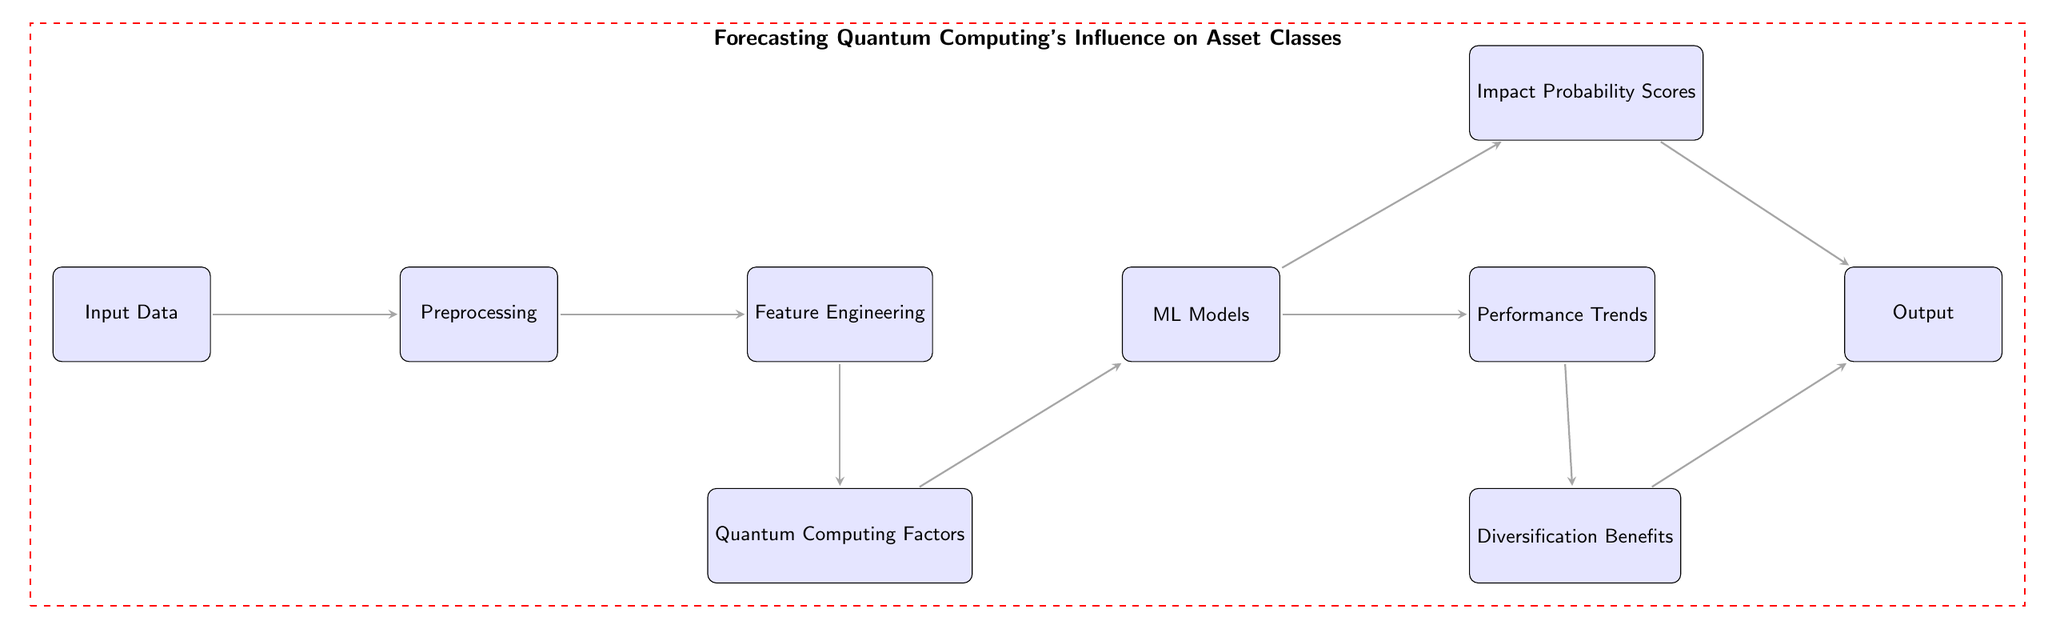What is the first node of the diagram? The first node in the diagram is labeled "Input Data," which indicates it is the initial stage of the process.
Answer: Input Data How many main nodes are involved in the processing flow? The diagram has a total of nine main nodes, each representing a step in the process of forecasting quantum computing's influence.
Answer: Nine What type of model is utilized in the diagram? The diagram specifies the use of "ML Models," indicating that machine learning methodologies are being applied in the forecasting process.
Answer: ML Models Which node corresponds to diversification benefits? The node that represents diversification benefits is labeled "Diversification Benefits," showing it is an output derived from the model's results.
Answer: Diversification Benefits How does the "Quantum Computing Factors" influence the "ML Models"? The "Quantum Computing Factors" node contributes data and considerations to the "ML Models," implying that factors related to quantum computing are essential inputs for the modeling process.
Answer: Through input What are the two outputs generated from "ML Models"? The two outputs from the "ML Models" are "Impact Probability Scores" and "Performance Trends," indicating different aspects of the forecasting results.
Answer: Impact Probability Scores and Performance Trends Which nodes feed directly into the final output node? The final output node receives inputs from "Impact Probability Scores" and "Diversification Benefits," which together inform the overall result provided by the model.
Answer: Impact Probability Scores and Diversification Benefits Identify the relationship between "Performance Trends" and "Diversification Benefits." The relationship is that both "Performance Trends" and "Diversification Benefits" inform the final output, showing that they represent different computations contributing to the overall forecasting results.
Answer: Both contribute to the output What visual cue indicates a separate grouping of nodes in the diagram? The diagram uses a dashed red box to encompass all the nodes, signifying that they are collectively part of the forecasting process being analyzed.
Answer: Dashed red box 